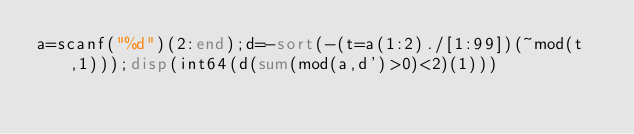<code> <loc_0><loc_0><loc_500><loc_500><_Octave_>a=scanf("%d")(2:end);d=-sort(-(t=a(1:2)./[1:99])(~mod(t,1)));disp(int64(d(sum(mod(a,d')>0)<2)(1)))</code> 